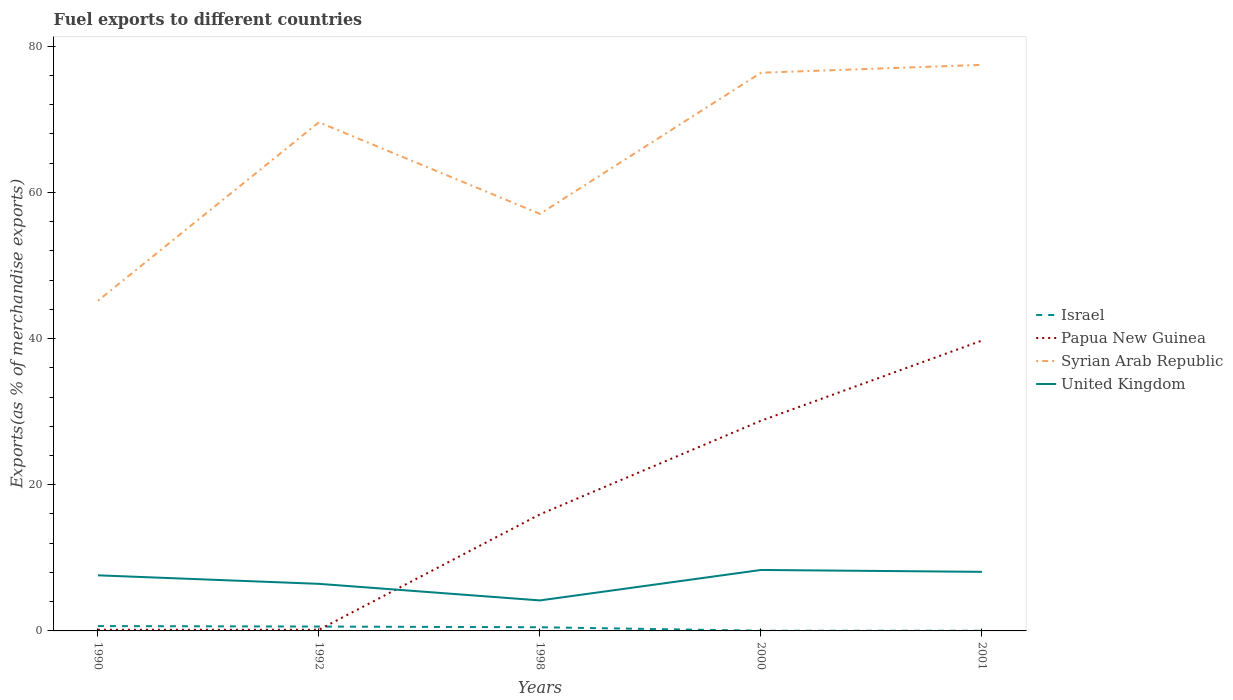How many different coloured lines are there?
Make the answer very short. 4. Does the line corresponding to Israel intersect with the line corresponding to United Kingdom?
Your answer should be very brief. No. Across all years, what is the maximum percentage of exports to different countries in United Kingdom?
Your answer should be very brief. 4.17. In which year was the percentage of exports to different countries in Papua New Guinea maximum?
Ensure brevity in your answer.  1990. What is the total percentage of exports to different countries in United Kingdom in the graph?
Your answer should be compact. -1.9. What is the difference between the highest and the second highest percentage of exports to different countries in United Kingdom?
Give a very brief answer. 4.17. How many lines are there?
Ensure brevity in your answer.  4. What is the difference between two consecutive major ticks on the Y-axis?
Make the answer very short. 20. Are the values on the major ticks of Y-axis written in scientific E-notation?
Provide a succinct answer. No. Does the graph contain any zero values?
Make the answer very short. No. Does the graph contain grids?
Your response must be concise. No. How many legend labels are there?
Provide a succinct answer. 4. How are the legend labels stacked?
Provide a short and direct response. Vertical. What is the title of the graph?
Your answer should be compact. Fuel exports to different countries. What is the label or title of the X-axis?
Ensure brevity in your answer.  Years. What is the label or title of the Y-axis?
Your answer should be compact. Exports(as % of merchandise exports). What is the Exports(as % of merchandise exports) in Israel in 1990?
Your answer should be very brief. 0.66. What is the Exports(as % of merchandise exports) of Papua New Guinea in 1990?
Keep it short and to the point. 0.16. What is the Exports(as % of merchandise exports) in Syrian Arab Republic in 1990?
Give a very brief answer. 45.17. What is the Exports(as % of merchandise exports) of United Kingdom in 1990?
Give a very brief answer. 7.6. What is the Exports(as % of merchandise exports) of Israel in 1992?
Provide a short and direct response. 0.6. What is the Exports(as % of merchandise exports) in Papua New Guinea in 1992?
Your response must be concise. 0.16. What is the Exports(as % of merchandise exports) of Syrian Arab Republic in 1992?
Your answer should be compact. 69.59. What is the Exports(as % of merchandise exports) in United Kingdom in 1992?
Offer a very short reply. 6.44. What is the Exports(as % of merchandise exports) of Israel in 1998?
Make the answer very short. 0.5. What is the Exports(as % of merchandise exports) in Papua New Guinea in 1998?
Give a very brief answer. 15.95. What is the Exports(as % of merchandise exports) of Syrian Arab Republic in 1998?
Ensure brevity in your answer.  57.05. What is the Exports(as % of merchandise exports) of United Kingdom in 1998?
Offer a terse response. 4.17. What is the Exports(as % of merchandise exports) in Israel in 2000?
Offer a terse response. 0.02. What is the Exports(as % of merchandise exports) in Papua New Guinea in 2000?
Give a very brief answer. 28.75. What is the Exports(as % of merchandise exports) of Syrian Arab Republic in 2000?
Offer a terse response. 76.36. What is the Exports(as % of merchandise exports) of United Kingdom in 2000?
Your response must be concise. 8.34. What is the Exports(as % of merchandise exports) of Israel in 2001?
Make the answer very short. 0.02. What is the Exports(as % of merchandise exports) in Papua New Guinea in 2001?
Offer a very short reply. 39.72. What is the Exports(as % of merchandise exports) in Syrian Arab Republic in 2001?
Make the answer very short. 77.44. What is the Exports(as % of merchandise exports) in United Kingdom in 2001?
Provide a short and direct response. 8.08. Across all years, what is the maximum Exports(as % of merchandise exports) in Israel?
Offer a terse response. 0.66. Across all years, what is the maximum Exports(as % of merchandise exports) of Papua New Guinea?
Provide a succinct answer. 39.72. Across all years, what is the maximum Exports(as % of merchandise exports) in Syrian Arab Republic?
Provide a succinct answer. 77.44. Across all years, what is the maximum Exports(as % of merchandise exports) in United Kingdom?
Make the answer very short. 8.34. Across all years, what is the minimum Exports(as % of merchandise exports) of Israel?
Your answer should be very brief. 0.02. Across all years, what is the minimum Exports(as % of merchandise exports) of Papua New Guinea?
Keep it short and to the point. 0.16. Across all years, what is the minimum Exports(as % of merchandise exports) of Syrian Arab Republic?
Provide a short and direct response. 45.17. Across all years, what is the minimum Exports(as % of merchandise exports) in United Kingdom?
Keep it short and to the point. 4.17. What is the total Exports(as % of merchandise exports) in Israel in the graph?
Provide a short and direct response. 1.81. What is the total Exports(as % of merchandise exports) in Papua New Guinea in the graph?
Make the answer very short. 84.75. What is the total Exports(as % of merchandise exports) in Syrian Arab Republic in the graph?
Give a very brief answer. 325.61. What is the total Exports(as % of merchandise exports) in United Kingdom in the graph?
Offer a very short reply. 34.64. What is the difference between the Exports(as % of merchandise exports) in Israel in 1990 and that in 1992?
Give a very brief answer. 0.07. What is the difference between the Exports(as % of merchandise exports) in Papua New Guinea in 1990 and that in 1992?
Make the answer very short. -0. What is the difference between the Exports(as % of merchandise exports) in Syrian Arab Republic in 1990 and that in 1992?
Give a very brief answer. -24.42. What is the difference between the Exports(as % of merchandise exports) in United Kingdom in 1990 and that in 1992?
Your response must be concise. 1.16. What is the difference between the Exports(as % of merchandise exports) of Israel in 1990 and that in 1998?
Make the answer very short. 0.16. What is the difference between the Exports(as % of merchandise exports) of Papua New Guinea in 1990 and that in 1998?
Ensure brevity in your answer.  -15.79. What is the difference between the Exports(as % of merchandise exports) in Syrian Arab Republic in 1990 and that in 1998?
Offer a very short reply. -11.88. What is the difference between the Exports(as % of merchandise exports) of United Kingdom in 1990 and that in 1998?
Provide a succinct answer. 3.43. What is the difference between the Exports(as % of merchandise exports) in Israel in 1990 and that in 2000?
Your response must be concise. 0.64. What is the difference between the Exports(as % of merchandise exports) in Papua New Guinea in 1990 and that in 2000?
Your answer should be compact. -28.59. What is the difference between the Exports(as % of merchandise exports) of Syrian Arab Republic in 1990 and that in 2000?
Offer a very short reply. -31.19. What is the difference between the Exports(as % of merchandise exports) of United Kingdom in 1990 and that in 2000?
Ensure brevity in your answer.  -0.73. What is the difference between the Exports(as % of merchandise exports) in Israel in 1990 and that in 2001?
Provide a succinct answer. 0.64. What is the difference between the Exports(as % of merchandise exports) in Papua New Guinea in 1990 and that in 2001?
Your answer should be very brief. -39.56. What is the difference between the Exports(as % of merchandise exports) of Syrian Arab Republic in 1990 and that in 2001?
Your response must be concise. -32.27. What is the difference between the Exports(as % of merchandise exports) in United Kingdom in 1990 and that in 2001?
Give a very brief answer. -0.48. What is the difference between the Exports(as % of merchandise exports) of Israel in 1992 and that in 1998?
Provide a short and direct response. 0.09. What is the difference between the Exports(as % of merchandise exports) in Papua New Guinea in 1992 and that in 1998?
Offer a very short reply. -15.79. What is the difference between the Exports(as % of merchandise exports) in Syrian Arab Republic in 1992 and that in 1998?
Offer a very short reply. 12.53. What is the difference between the Exports(as % of merchandise exports) of United Kingdom in 1992 and that in 1998?
Ensure brevity in your answer.  2.27. What is the difference between the Exports(as % of merchandise exports) of Israel in 1992 and that in 2000?
Offer a terse response. 0.57. What is the difference between the Exports(as % of merchandise exports) in Papua New Guinea in 1992 and that in 2000?
Provide a short and direct response. -28.59. What is the difference between the Exports(as % of merchandise exports) of Syrian Arab Republic in 1992 and that in 2000?
Make the answer very short. -6.78. What is the difference between the Exports(as % of merchandise exports) of United Kingdom in 1992 and that in 2000?
Offer a terse response. -1.9. What is the difference between the Exports(as % of merchandise exports) of Israel in 1992 and that in 2001?
Your response must be concise. 0.57. What is the difference between the Exports(as % of merchandise exports) in Papua New Guinea in 1992 and that in 2001?
Your answer should be compact. -39.56. What is the difference between the Exports(as % of merchandise exports) in Syrian Arab Republic in 1992 and that in 2001?
Offer a very short reply. -7.85. What is the difference between the Exports(as % of merchandise exports) of United Kingdom in 1992 and that in 2001?
Offer a terse response. -1.64. What is the difference between the Exports(as % of merchandise exports) of Israel in 1998 and that in 2000?
Your answer should be compact. 0.48. What is the difference between the Exports(as % of merchandise exports) in Papua New Guinea in 1998 and that in 2000?
Provide a succinct answer. -12.81. What is the difference between the Exports(as % of merchandise exports) in Syrian Arab Republic in 1998 and that in 2000?
Give a very brief answer. -19.31. What is the difference between the Exports(as % of merchandise exports) of United Kingdom in 1998 and that in 2000?
Offer a very short reply. -4.17. What is the difference between the Exports(as % of merchandise exports) of Israel in 1998 and that in 2001?
Your answer should be very brief. 0.48. What is the difference between the Exports(as % of merchandise exports) of Papua New Guinea in 1998 and that in 2001?
Keep it short and to the point. -23.78. What is the difference between the Exports(as % of merchandise exports) in Syrian Arab Republic in 1998 and that in 2001?
Offer a very short reply. -20.38. What is the difference between the Exports(as % of merchandise exports) of United Kingdom in 1998 and that in 2001?
Your response must be concise. -3.91. What is the difference between the Exports(as % of merchandise exports) of Israel in 2000 and that in 2001?
Make the answer very short. -0. What is the difference between the Exports(as % of merchandise exports) in Papua New Guinea in 2000 and that in 2001?
Your response must be concise. -10.97. What is the difference between the Exports(as % of merchandise exports) of Syrian Arab Republic in 2000 and that in 2001?
Provide a succinct answer. -1.08. What is the difference between the Exports(as % of merchandise exports) of United Kingdom in 2000 and that in 2001?
Make the answer very short. 0.26. What is the difference between the Exports(as % of merchandise exports) in Israel in 1990 and the Exports(as % of merchandise exports) in Papua New Guinea in 1992?
Provide a succinct answer. 0.5. What is the difference between the Exports(as % of merchandise exports) of Israel in 1990 and the Exports(as % of merchandise exports) of Syrian Arab Republic in 1992?
Provide a short and direct response. -68.92. What is the difference between the Exports(as % of merchandise exports) in Israel in 1990 and the Exports(as % of merchandise exports) in United Kingdom in 1992?
Ensure brevity in your answer.  -5.78. What is the difference between the Exports(as % of merchandise exports) of Papua New Guinea in 1990 and the Exports(as % of merchandise exports) of Syrian Arab Republic in 1992?
Your answer should be very brief. -69.43. What is the difference between the Exports(as % of merchandise exports) of Papua New Guinea in 1990 and the Exports(as % of merchandise exports) of United Kingdom in 1992?
Your answer should be very brief. -6.28. What is the difference between the Exports(as % of merchandise exports) of Syrian Arab Republic in 1990 and the Exports(as % of merchandise exports) of United Kingdom in 1992?
Provide a succinct answer. 38.73. What is the difference between the Exports(as % of merchandise exports) of Israel in 1990 and the Exports(as % of merchandise exports) of Papua New Guinea in 1998?
Your answer should be very brief. -15.28. What is the difference between the Exports(as % of merchandise exports) of Israel in 1990 and the Exports(as % of merchandise exports) of Syrian Arab Republic in 1998?
Offer a very short reply. -56.39. What is the difference between the Exports(as % of merchandise exports) of Israel in 1990 and the Exports(as % of merchandise exports) of United Kingdom in 1998?
Make the answer very short. -3.51. What is the difference between the Exports(as % of merchandise exports) in Papua New Guinea in 1990 and the Exports(as % of merchandise exports) in Syrian Arab Republic in 1998?
Keep it short and to the point. -56.89. What is the difference between the Exports(as % of merchandise exports) in Papua New Guinea in 1990 and the Exports(as % of merchandise exports) in United Kingdom in 1998?
Provide a succinct answer. -4.01. What is the difference between the Exports(as % of merchandise exports) of Syrian Arab Republic in 1990 and the Exports(as % of merchandise exports) of United Kingdom in 1998?
Provide a short and direct response. 41. What is the difference between the Exports(as % of merchandise exports) in Israel in 1990 and the Exports(as % of merchandise exports) in Papua New Guinea in 2000?
Ensure brevity in your answer.  -28.09. What is the difference between the Exports(as % of merchandise exports) in Israel in 1990 and the Exports(as % of merchandise exports) in Syrian Arab Republic in 2000?
Offer a terse response. -75.7. What is the difference between the Exports(as % of merchandise exports) of Israel in 1990 and the Exports(as % of merchandise exports) of United Kingdom in 2000?
Your response must be concise. -7.68. What is the difference between the Exports(as % of merchandise exports) of Papua New Guinea in 1990 and the Exports(as % of merchandise exports) of Syrian Arab Republic in 2000?
Offer a terse response. -76.2. What is the difference between the Exports(as % of merchandise exports) in Papua New Guinea in 1990 and the Exports(as % of merchandise exports) in United Kingdom in 2000?
Provide a succinct answer. -8.18. What is the difference between the Exports(as % of merchandise exports) of Syrian Arab Republic in 1990 and the Exports(as % of merchandise exports) of United Kingdom in 2000?
Keep it short and to the point. 36.83. What is the difference between the Exports(as % of merchandise exports) in Israel in 1990 and the Exports(as % of merchandise exports) in Papua New Guinea in 2001?
Make the answer very short. -39.06. What is the difference between the Exports(as % of merchandise exports) of Israel in 1990 and the Exports(as % of merchandise exports) of Syrian Arab Republic in 2001?
Offer a terse response. -76.77. What is the difference between the Exports(as % of merchandise exports) of Israel in 1990 and the Exports(as % of merchandise exports) of United Kingdom in 2001?
Ensure brevity in your answer.  -7.42. What is the difference between the Exports(as % of merchandise exports) in Papua New Guinea in 1990 and the Exports(as % of merchandise exports) in Syrian Arab Republic in 2001?
Offer a terse response. -77.28. What is the difference between the Exports(as % of merchandise exports) in Papua New Guinea in 1990 and the Exports(as % of merchandise exports) in United Kingdom in 2001?
Give a very brief answer. -7.92. What is the difference between the Exports(as % of merchandise exports) of Syrian Arab Republic in 1990 and the Exports(as % of merchandise exports) of United Kingdom in 2001?
Provide a succinct answer. 37.09. What is the difference between the Exports(as % of merchandise exports) of Israel in 1992 and the Exports(as % of merchandise exports) of Papua New Guinea in 1998?
Your response must be concise. -15.35. What is the difference between the Exports(as % of merchandise exports) in Israel in 1992 and the Exports(as % of merchandise exports) in Syrian Arab Republic in 1998?
Ensure brevity in your answer.  -56.46. What is the difference between the Exports(as % of merchandise exports) in Israel in 1992 and the Exports(as % of merchandise exports) in United Kingdom in 1998?
Give a very brief answer. -3.58. What is the difference between the Exports(as % of merchandise exports) of Papua New Guinea in 1992 and the Exports(as % of merchandise exports) of Syrian Arab Republic in 1998?
Give a very brief answer. -56.89. What is the difference between the Exports(as % of merchandise exports) in Papua New Guinea in 1992 and the Exports(as % of merchandise exports) in United Kingdom in 1998?
Give a very brief answer. -4.01. What is the difference between the Exports(as % of merchandise exports) of Syrian Arab Republic in 1992 and the Exports(as % of merchandise exports) of United Kingdom in 1998?
Your response must be concise. 65.41. What is the difference between the Exports(as % of merchandise exports) in Israel in 1992 and the Exports(as % of merchandise exports) in Papua New Guinea in 2000?
Ensure brevity in your answer.  -28.16. What is the difference between the Exports(as % of merchandise exports) in Israel in 1992 and the Exports(as % of merchandise exports) in Syrian Arab Republic in 2000?
Provide a short and direct response. -75.76. What is the difference between the Exports(as % of merchandise exports) of Israel in 1992 and the Exports(as % of merchandise exports) of United Kingdom in 2000?
Offer a terse response. -7.74. What is the difference between the Exports(as % of merchandise exports) of Papua New Guinea in 1992 and the Exports(as % of merchandise exports) of Syrian Arab Republic in 2000?
Provide a succinct answer. -76.2. What is the difference between the Exports(as % of merchandise exports) of Papua New Guinea in 1992 and the Exports(as % of merchandise exports) of United Kingdom in 2000?
Ensure brevity in your answer.  -8.18. What is the difference between the Exports(as % of merchandise exports) in Syrian Arab Republic in 1992 and the Exports(as % of merchandise exports) in United Kingdom in 2000?
Provide a short and direct response. 61.25. What is the difference between the Exports(as % of merchandise exports) of Israel in 1992 and the Exports(as % of merchandise exports) of Papua New Guinea in 2001?
Make the answer very short. -39.13. What is the difference between the Exports(as % of merchandise exports) in Israel in 1992 and the Exports(as % of merchandise exports) in Syrian Arab Republic in 2001?
Provide a short and direct response. -76.84. What is the difference between the Exports(as % of merchandise exports) of Israel in 1992 and the Exports(as % of merchandise exports) of United Kingdom in 2001?
Provide a short and direct response. -7.48. What is the difference between the Exports(as % of merchandise exports) of Papua New Guinea in 1992 and the Exports(as % of merchandise exports) of Syrian Arab Republic in 2001?
Keep it short and to the point. -77.28. What is the difference between the Exports(as % of merchandise exports) in Papua New Guinea in 1992 and the Exports(as % of merchandise exports) in United Kingdom in 2001?
Offer a very short reply. -7.92. What is the difference between the Exports(as % of merchandise exports) of Syrian Arab Republic in 1992 and the Exports(as % of merchandise exports) of United Kingdom in 2001?
Ensure brevity in your answer.  61.5. What is the difference between the Exports(as % of merchandise exports) of Israel in 1998 and the Exports(as % of merchandise exports) of Papua New Guinea in 2000?
Your response must be concise. -28.25. What is the difference between the Exports(as % of merchandise exports) in Israel in 1998 and the Exports(as % of merchandise exports) in Syrian Arab Republic in 2000?
Make the answer very short. -75.86. What is the difference between the Exports(as % of merchandise exports) in Israel in 1998 and the Exports(as % of merchandise exports) in United Kingdom in 2000?
Give a very brief answer. -7.84. What is the difference between the Exports(as % of merchandise exports) of Papua New Guinea in 1998 and the Exports(as % of merchandise exports) of Syrian Arab Republic in 2000?
Offer a terse response. -60.41. What is the difference between the Exports(as % of merchandise exports) of Papua New Guinea in 1998 and the Exports(as % of merchandise exports) of United Kingdom in 2000?
Your answer should be very brief. 7.61. What is the difference between the Exports(as % of merchandise exports) in Syrian Arab Republic in 1998 and the Exports(as % of merchandise exports) in United Kingdom in 2000?
Give a very brief answer. 48.71. What is the difference between the Exports(as % of merchandise exports) in Israel in 1998 and the Exports(as % of merchandise exports) in Papua New Guinea in 2001?
Ensure brevity in your answer.  -39.22. What is the difference between the Exports(as % of merchandise exports) in Israel in 1998 and the Exports(as % of merchandise exports) in Syrian Arab Republic in 2001?
Your answer should be compact. -76.93. What is the difference between the Exports(as % of merchandise exports) in Israel in 1998 and the Exports(as % of merchandise exports) in United Kingdom in 2001?
Ensure brevity in your answer.  -7.58. What is the difference between the Exports(as % of merchandise exports) in Papua New Guinea in 1998 and the Exports(as % of merchandise exports) in Syrian Arab Republic in 2001?
Offer a very short reply. -61.49. What is the difference between the Exports(as % of merchandise exports) in Papua New Guinea in 1998 and the Exports(as % of merchandise exports) in United Kingdom in 2001?
Your response must be concise. 7.87. What is the difference between the Exports(as % of merchandise exports) of Syrian Arab Republic in 1998 and the Exports(as % of merchandise exports) of United Kingdom in 2001?
Offer a terse response. 48.97. What is the difference between the Exports(as % of merchandise exports) in Israel in 2000 and the Exports(as % of merchandise exports) in Papua New Guinea in 2001?
Your response must be concise. -39.7. What is the difference between the Exports(as % of merchandise exports) of Israel in 2000 and the Exports(as % of merchandise exports) of Syrian Arab Republic in 2001?
Make the answer very short. -77.41. What is the difference between the Exports(as % of merchandise exports) in Israel in 2000 and the Exports(as % of merchandise exports) in United Kingdom in 2001?
Provide a succinct answer. -8.06. What is the difference between the Exports(as % of merchandise exports) in Papua New Guinea in 2000 and the Exports(as % of merchandise exports) in Syrian Arab Republic in 2001?
Offer a terse response. -48.68. What is the difference between the Exports(as % of merchandise exports) in Papua New Guinea in 2000 and the Exports(as % of merchandise exports) in United Kingdom in 2001?
Provide a succinct answer. 20.67. What is the difference between the Exports(as % of merchandise exports) of Syrian Arab Republic in 2000 and the Exports(as % of merchandise exports) of United Kingdom in 2001?
Make the answer very short. 68.28. What is the average Exports(as % of merchandise exports) of Israel per year?
Offer a terse response. 0.36. What is the average Exports(as % of merchandise exports) of Papua New Guinea per year?
Provide a succinct answer. 16.95. What is the average Exports(as % of merchandise exports) in Syrian Arab Republic per year?
Make the answer very short. 65.12. What is the average Exports(as % of merchandise exports) of United Kingdom per year?
Your answer should be compact. 6.93. In the year 1990, what is the difference between the Exports(as % of merchandise exports) of Israel and Exports(as % of merchandise exports) of Papua New Guinea?
Keep it short and to the point. 0.5. In the year 1990, what is the difference between the Exports(as % of merchandise exports) of Israel and Exports(as % of merchandise exports) of Syrian Arab Republic?
Ensure brevity in your answer.  -44.51. In the year 1990, what is the difference between the Exports(as % of merchandise exports) in Israel and Exports(as % of merchandise exports) in United Kingdom?
Offer a very short reply. -6.94. In the year 1990, what is the difference between the Exports(as % of merchandise exports) of Papua New Guinea and Exports(as % of merchandise exports) of Syrian Arab Republic?
Provide a short and direct response. -45.01. In the year 1990, what is the difference between the Exports(as % of merchandise exports) in Papua New Guinea and Exports(as % of merchandise exports) in United Kingdom?
Make the answer very short. -7.44. In the year 1990, what is the difference between the Exports(as % of merchandise exports) in Syrian Arab Republic and Exports(as % of merchandise exports) in United Kingdom?
Provide a succinct answer. 37.57. In the year 1992, what is the difference between the Exports(as % of merchandise exports) of Israel and Exports(as % of merchandise exports) of Papua New Guinea?
Your answer should be compact. 0.44. In the year 1992, what is the difference between the Exports(as % of merchandise exports) of Israel and Exports(as % of merchandise exports) of Syrian Arab Republic?
Your answer should be very brief. -68.99. In the year 1992, what is the difference between the Exports(as % of merchandise exports) of Israel and Exports(as % of merchandise exports) of United Kingdom?
Provide a succinct answer. -5.84. In the year 1992, what is the difference between the Exports(as % of merchandise exports) of Papua New Guinea and Exports(as % of merchandise exports) of Syrian Arab Republic?
Keep it short and to the point. -69.42. In the year 1992, what is the difference between the Exports(as % of merchandise exports) in Papua New Guinea and Exports(as % of merchandise exports) in United Kingdom?
Provide a short and direct response. -6.28. In the year 1992, what is the difference between the Exports(as % of merchandise exports) of Syrian Arab Republic and Exports(as % of merchandise exports) of United Kingdom?
Offer a very short reply. 63.15. In the year 1998, what is the difference between the Exports(as % of merchandise exports) of Israel and Exports(as % of merchandise exports) of Papua New Guinea?
Make the answer very short. -15.44. In the year 1998, what is the difference between the Exports(as % of merchandise exports) of Israel and Exports(as % of merchandise exports) of Syrian Arab Republic?
Your answer should be compact. -56.55. In the year 1998, what is the difference between the Exports(as % of merchandise exports) in Israel and Exports(as % of merchandise exports) in United Kingdom?
Keep it short and to the point. -3.67. In the year 1998, what is the difference between the Exports(as % of merchandise exports) in Papua New Guinea and Exports(as % of merchandise exports) in Syrian Arab Republic?
Provide a succinct answer. -41.11. In the year 1998, what is the difference between the Exports(as % of merchandise exports) of Papua New Guinea and Exports(as % of merchandise exports) of United Kingdom?
Make the answer very short. 11.78. In the year 1998, what is the difference between the Exports(as % of merchandise exports) of Syrian Arab Republic and Exports(as % of merchandise exports) of United Kingdom?
Offer a terse response. 52.88. In the year 2000, what is the difference between the Exports(as % of merchandise exports) in Israel and Exports(as % of merchandise exports) in Papua New Guinea?
Your answer should be very brief. -28.73. In the year 2000, what is the difference between the Exports(as % of merchandise exports) in Israel and Exports(as % of merchandise exports) in Syrian Arab Republic?
Make the answer very short. -76.34. In the year 2000, what is the difference between the Exports(as % of merchandise exports) in Israel and Exports(as % of merchandise exports) in United Kingdom?
Your answer should be compact. -8.32. In the year 2000, what is the difference between the Exports(as % of merchandise exports) of Papua New Guinea and Exports(as % of merchandise exports) of Syrian Arab Republic?
Provide a succinct answer. -47.61. In the year 2000, what is the difference between the Exports(as % of merchandise exports) of Papua New Guinea and Exports(as % of merchandise exports) of United Kingdom?
Your response must be concise. 20.41. In the year 2000, what is the difference between the Exports(as % of merchandise exports) of Syrian Arab Republic and Exports(as % of merchandise exports) of United Kingdom?
Your answer should be compact. 68.02. In the year 2001, what is the difference between the Exports(as % of merchandise exports) in Israel and Exports(as % of merchandise exports) in Papua New Guinea?
Offer a very short reply. -39.7. In the year 2001, what is the difference between the Exports(as % of merchandise exports) of Israel and Exports(as % of merchandise exports) of Syrian Arab Republic?
Keep it short and to the point. -77.41. In the year 2001, what is the difference between the Exports(as % of merchandise exports) of Israel and Exports(as % of merchandise exports) of United Kingdom?
Make the answer very short. -8.06. In the year 2001, what is the difference between the Exports(as % of merchandise exports) of Papua New Guinea and Exports(as % of merchandise exports) of Syrian Arab Republic?
Your answer should be compact. -37.71. In the year 2001, what is the difference between the Exports(as % of merchandise exports) of Papua New Guinea and Exports(as % of merchandise exports) of United Kingdom?
Offer a very short reply. 31.64. In the year 2001, what is the difference between the Exports(as % of merchandise exports) in Syrian Arab Republic and Exports(as % of merchandise exports) in United Kingdom?
Make the answer very short. 69.36. What is the ratio of the Exports(as % of merchandise exports) in Israel in 1990 to that in 1992?
Your answer should be compact. 1.11. What is the ratio of the Exports(as % of merchandise exports) in Papua New Guinea in 1990 to that in 1992?
Make the answer very short. 0.99. What is the ratio of the Exports(as % of merchandise exports) in Syrian Arab Republic in 1990 to that in 1992?
Ensure brevity in your answer.  0.65. What is the ratio of the Exports(as % of merchandise exports) of United Kingdom in 1990 to that in 1992?
Ensure brevity in your answer.  1.18. What is the ratio of the Exports(as % of merchandise exports) in Israel in 1990 to that in 1998?
Make the answer very short. 1.32. What is the ratio of the Exports(as % of merchandise exports) in Syrian Arab Republic in 1990 to that in 1998?
Ensure brevity in your answer.  0.79. What is the ratio of the Exports(as % of merchandise exports) of United Kingdom in 1990 to that in 1998?
Your response must be concise. 1.82. What is the ratio of the Exports(as % of merchandise exports) of Israel in 1990 to that in 2000?
Your answer should be compact. 27.71. What is the ratio of the Exports(as % of merchandise exports) of Papua New Guinea in 1990 to that in 2000?
Your response must be concise. 0.01. What is the ratio of the Exports(as % of merchandise exports) of Syrian Arab Republic in 1990 to that in 2000?
Make the answer very short. 0.59. What is the ratio of the Exports(as % of merchandise exports) in United Kingdom in 1990 to that in 2000?
Offer a terse response. 0.91. What is the ratio of the Exports(as % of merchandise exports) of Israel in 1990 to that in 2001?
Provide a succinct answer. 27.09. What is the ratio of the Exports(as % of merchandise exports) in Papua New Guinea in 1990 to that in 2001?
Your answer should be compact. 0. What is the ratio of the Exports(as % of merchandise exports) of Syrian Arab Republic in 1990 to that in 2001?
Give a very brief answer. 0.58. What is the ratio of the Exports(as % of merchandise exports) in United Kingdom in 1990 to that in 2001?
Offer a terse response. 0.94. What is the ratio of the Exports(as % of merchandise exports) of Israel in 1992 to that in 1998?
Provide a short and direct response. 1.19. What is the ratio of the Exports(as % of merchandise exports) of Papua New Guinea in 1992 to that in 1998?
Your answer should be compact. 0.01. What is the ratio of the Exports(as % of merchandise exports) of Syrian Arab Republic in 1992 to that in 1998?
Offer a terse response. 1.22. What is the ratio of the Exports(as % of merchandise exports) in United Kingdom in 1992 to that in 1998?
Keep it short and to the point. 1.54. What is the ratio of the Exports(as % of merchandise exports) in Israel in 1992 to that in 2000?
Offer a terse response. 24.94. What is the ratio of the Exports(as % of merchandise exports) of Papua New Guinea in 1992 to that in 2000?
Keep it short and to the point. 0.01. What is the ratio of the Exports(as % of merchandise exports) in Syrian Arab Republic in 1992 to that in 2000?
Provide a succinct answer. 0.91. What is the ratio of the Exports(as % of merchandise exports) in United Kingdom in 1992 to that in 2000?
Ensure brevity in your answer.  0.77. What is the ratio of the Exports(as % of merchandise exports) in Israel in 1992 to that in 2001?
Your answer should be compact. 24.38. What is the ratio of the Exports(as % of merchandise exports) in Papua New Guinea in 1992 to that in 2001?
Your response must be concise. 0. What is the ratio of the Exports(as % of merchandise exports) in Syrian Arab Republic in 1992 to that in 2001?
Provide a succinct answer. 0.9. What is the ratio of the Exports(as % of merchandise exports) of United Kingdom in 1992 to that in 2001?
Your answer should be compact. 0.8. What is the ratio of the Exports(as % of merchandise exports) of Israel in 1998 to that in 2000?
Keep it short and to the point. 21.03. What is the ratio of the Exports(as % of merchandise exports) in Papua New Guinea in 1998 to that in 2000?
Offer a very short reply. 0.55. What is the ratio of the Exports(as % of merchandise exports) of Syrian Arab Republic in 1998 to that in 2000?
Give a very brief answer. 0.75. What is the ratio of the Exports(as % of merchandise exports) in United Kingdom in 1998 to that in 2000?
Give a very brief answer. 0.5. What is the ratio of the Exports(as % of merchandise exports) of Israel in 1998 to that in 2001?
Offer a terse response. 20.56. What is the ratio of the Exports(as % of merchandise exports) in Papua New Guinea in 1998 to that in 2001?
Your answer should be compact. 0.4. What is the ratio of the Exports(as % of merchandise exports) in Syrian Arab Republic in 1998 to that in 2001?
Your answer should be very brief. 0.74. What is the ratio of the Exports(as % of merchandise exports) of United Kingdom in 1998 to that in 2001?
Provide a succinct answer. 0.52. What is the ratio of the Exports(as % of merchandise exports) in Israel in 2000 to that in 2001?
Offer a terse response. 0.98. What is the ratio of the Exports(as % of merchandise exports) of Papua New Guinea in 2000 to that in 2001?
Offer a terse response. 0.72. What is the ratio of the Exports(as % of merchandise exports) of Syrian Arab Republic in 2000 to that in 2001?
Your answer should be compact. 0.99. What is the ratio of the Exports(as % of merchandise exports) in United Kingdom in 2000 to that in 2001?
Offer a very short reply. 1.03. What is the difference between the highest and the second highest Exports(as % of merchandise exports) in Israel?
Provide a short and direct response. 0.07. What is the difference between the highest and the second highest Exports(as % of merchandise exports) of Papua New Guinea?
Offer a very short reply. 10.97. What is the difference between the highest and the second highest Exports(as % of merchandise exports) in Syrian Arab Republic?
Offer a terse response. 1.08. What is the difference between the highest and the second highest Exports(as % of merchandise exports) of United Kingdom?
Keep it short and to the point. 0.26. What is the difference between the highest and the lowest Exports(as % of merchandise exports) in Israel?
Your response must be concise. 0.64. What is the difference between the highest and the lowest Exports(as % of merchandise exports) of Papua New Guinea?
Ensure brevity in your answer.  39.56. What is the difference between the highest and the lowest Exports(as % of merchandise exports) of Syrian Arab Republic?
Give a very brief answer. 32.27. What is the difference between the highest and the lowest Exports(as % of merchandise exports) in United Kingdom?
Make the answer very short. 4.17. 